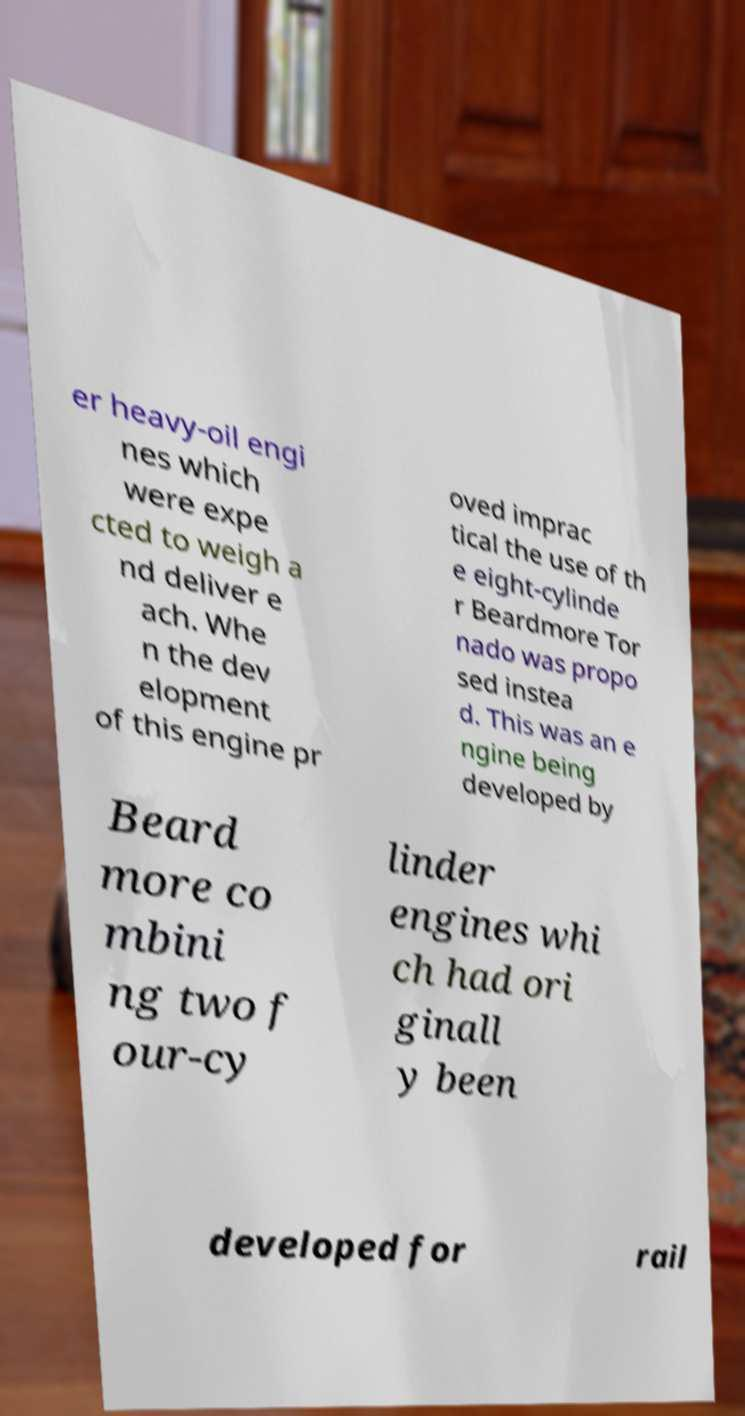There's text embedded in this image that I need extracted. Can you transcribe it verbatim? er heavy-oil engi nes which were expe cted to weigh a nd deliver e ach. Whe n the dev elopment of this engine pr oved imprac tical the use of th e eight-cylinde r Beardmore Tor nado was propo sed instea d. This was an e ngine being developed by Beard more co mbini ng two f our-cy linder engines whi ch had ori ginall y been developed for rail 